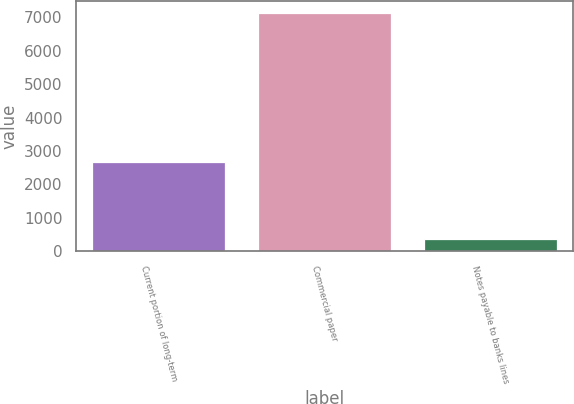<chart> <loc_0><loc_0><loc_500><loc_500><bar_chart><fcel>Current portion of long-term<fcel>Commercial paper<fcel>Notes payable to banks lines<nl><fcel>2674<fcel>7146<fcel>356<nl></chart> 